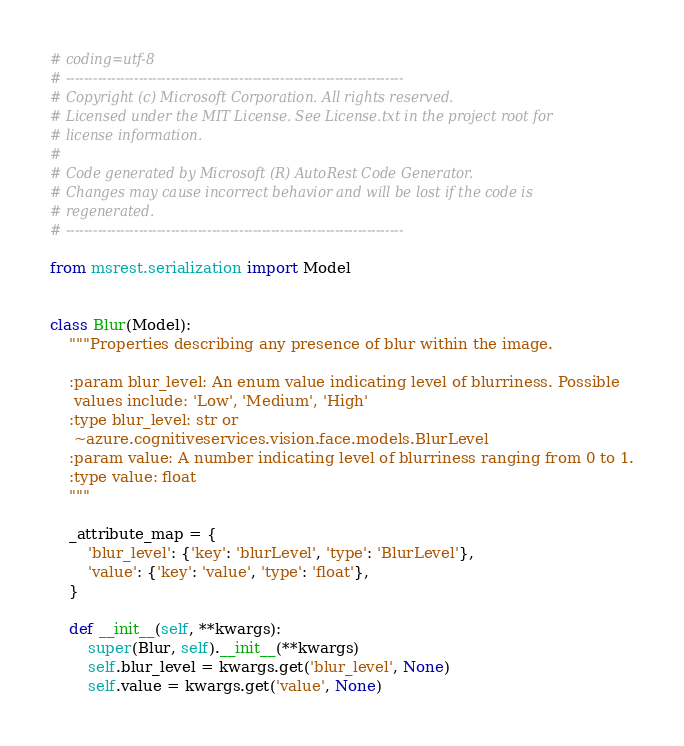Convert code to text. <code><loc_0><loc_0><loc_500><loc_500><_Python_># coding=utf-8
# --------------------------------------------------------------------------
# Copyright (c) Microsoft Corporation. All rights reserved.
# Licensed under the MIT License. See License.txt in the project root for
# license information.
#
# Code generated by Microsoft (R) AutoRest Code Generator.
# Changes may cause incorrect behavior and will be lost if the code is
# regenerated.
# --------------------------------------------------------------------------

from msrest.serialization import Model


class Blur(Model):
    """Properties describing any presence of blur within the image.

    :param blur_level: An enum value indicating level of blurriness. Possible
     values include: 'Low', 'Medium', 'High'
    :type blur_level: str or
     ~azure.cognitiveservices.vision.face.models.BlurLevel
    :param value: A number indicating level of blurriness ranging from 0 to 1.
    :type value: float
    """

    _attribute_map = {
        'blur_level': {'key': 'blurLevel', 'type': 'BlurLevel'},
        'value': {'key': 'value', 'type': 'float'},
    }

    def __init__(self, **kwargs):
        super(Blur, self).__init__(**kwargs)
        self.blur_level = kwargs.get('blur_level', None)
        self.value = kwargs.get('value', None)
</code> 